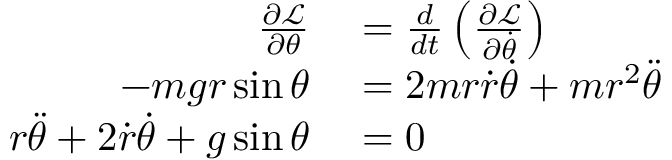<formula> <loc_0><loc_0><loc_500><loc_500>\begin{array} { r l } { { \frac { \partial { \mathcal { L } } } { \partial \theta } } } & = { \frac { d } { d t } } \left ( { \frac { \partial { \mathcal { L } } } { \partial { \dot { \theta } } } } \right ) } \\ { - m g r \sin { \theta } } & = 2 m r { \dot { r } } { \dot { \theta } } + m r ^ { 2 } { \ddot { \theta } } } \\ { r { \ddot { \theta } } + 2 { \dot { r } } { \dot { \theta } } + g \sin { \theta } } & = 0 } \end{array}</formula> 